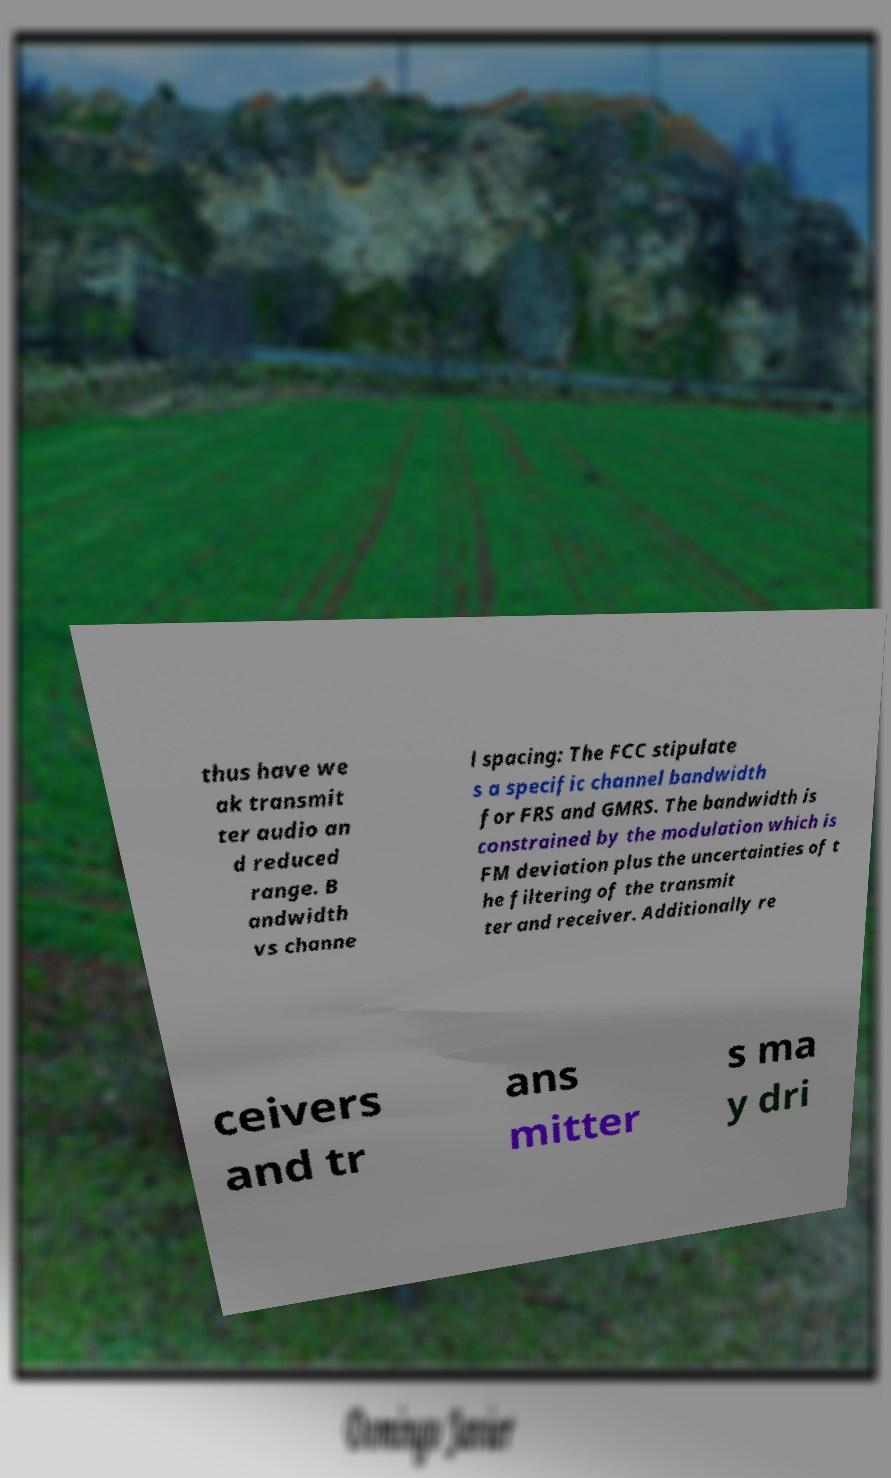Could you extract and type out the text from this image? thus have we ak transmit ter audio an d reduced range. B andwidth vs channe l spacing: The FCC stipulate s a specific channel bandwidth for FRS and GMRS. The bandwidth is constrained by the modulation which is FM deviation plus the uncertainties of t he filtering of the transmit ter and receiver. Additionally re ceivers and tr ans mitter s ma y dri 